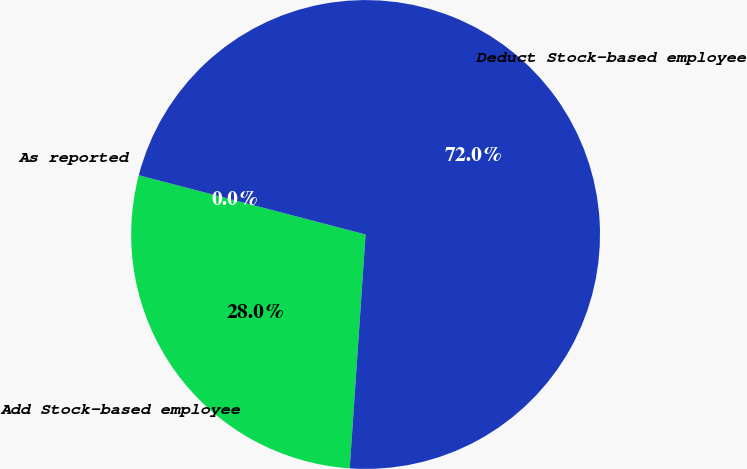<chart> <loc_0><loc_0><loc_500><loc_500><pie_chart><fcel>Add Stock-based employee<fcel>Deduct Stock-based employee<fcel>As reported<nl><fcel>27.99%<fcel>72.01%<fcel>0.0%<nl></chart> 